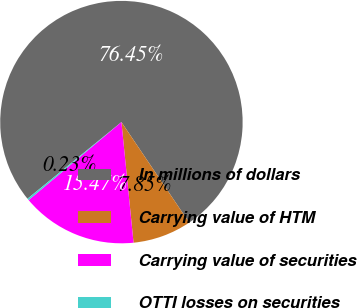<chart> <loc_0><loc_0><loc_500><loc_500><pie_chart><fcel>In millions of dollars<fcel>Carrying value of HTM<fcel>Carrying value of securities<fcel>OTTI losses on securities<nl><fcel>76.45%<fcel>7.85%<fcel>15.47%<fcel>0.23%<nl></chart> 